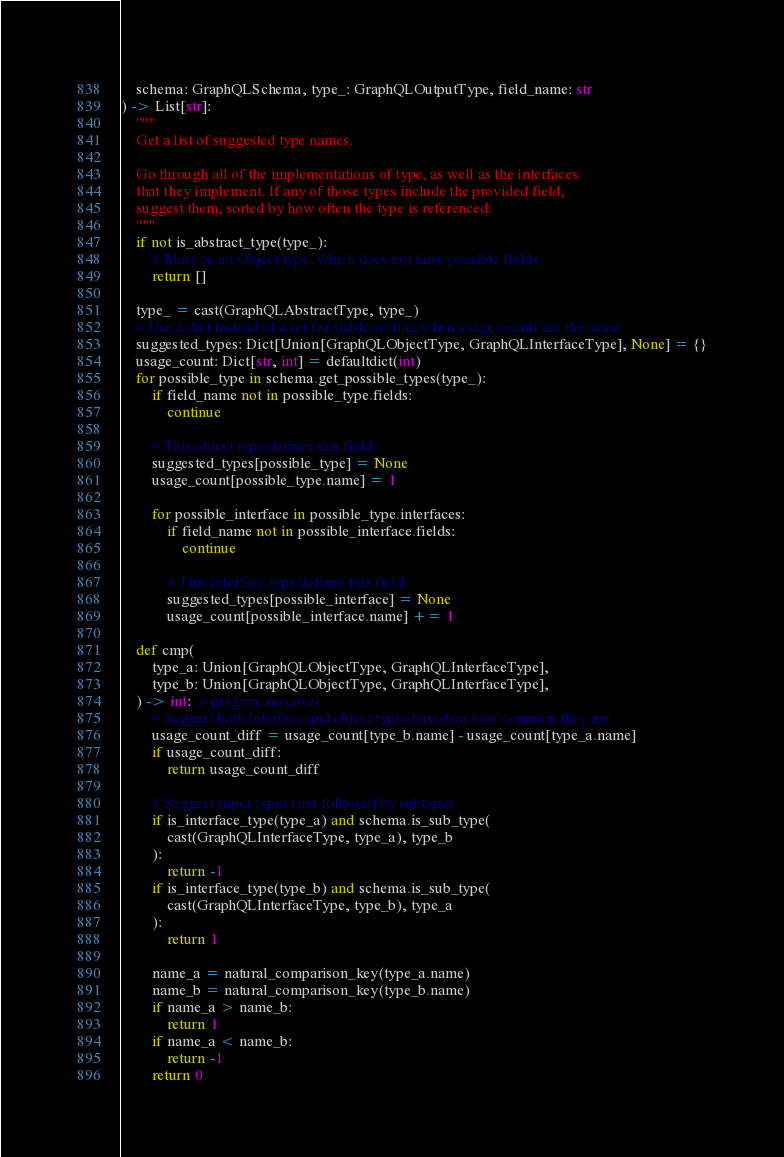Convert code to text. <code><loc_0><loc_0><loc_500><loc_500><_Python_>    schema: GraphQLSchema, type_: GraphQLOutputType, field_name: str
) -> List[str]:
    """
    Get a list of suggested type names.

    Go through all of the implementations of type, as well as the interfaces
    that they implement. If any of those types include the provided field,
    suggest them, sorted by how often the type is referenced.
    """
    if not is_abstract_type(type_):
        # Must be an Object type, which does not have possible fields.
        return []

    type_ = cast(GraphQLAbstractType, type_)
    # Use a dict instead of a set for stable sorting when usage counts are the same
    suggested_types: Dict[Union[GraphQLObjectType, GraphQLInterfaceType], None] = {}
    usage_count: Dict[str, int] = defaultdict(int)
    for possible_type in schema.get_possible_types(type_):
        if field_name not in possible_type.fields:
            continue

        # This object type defines this field.
        suggested_types[possible_type] = None
        usage_count[possible_type.name] = 1

        for possible_interface in possible_type.interfaces:
            if field_name not in possible_interface.fields:
                continue

            # This interface type defines this field.
            suggested_types[possible_interface] = None
            usage_count[possible_interface.name] += 1

    def cmp(
        type_a: Union[GraphQLObjectType, GraphQLInterfaceType],
        type_b: Union[GraphQLObjectType, GraphQLInterfaceType],
    ) -> int:  # pragma: no cover
        # Suggest both interface and object types based on how common they are.
        usage_count_diff = usage_count[type_b.name] - usage_count[type_a.name]
        if usage_count_diff:
            return usage_count_diff

        # Suggest super types first followed by subtypes
        if is_interface_type(type_a) and schema.is_sub_type(
            cast(GraphQLInterfaceType, type_a), type_b
        ):
            return -1
        if is_interface_type(type_b) and schema.is_sub_type(
            cast(GraphQLInterfaceType, type_b), type_a
        ):
            return 1

        name_a = natural_comparison_key(type_a.name)
        name_b = natural_comparison_key(type_b.name)
        if name_a > name_b:
            return 1
        if name_a < name_b:
            return -1
        return 0
</code> 